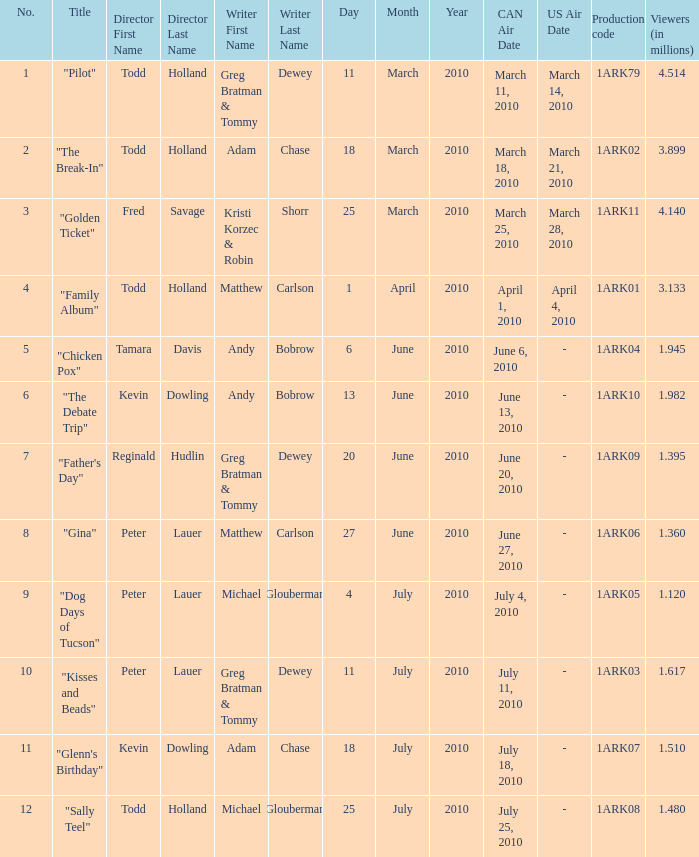What is the original air date for production code 1ark79? March11,2010 (CAN) March14,2010 (US). 